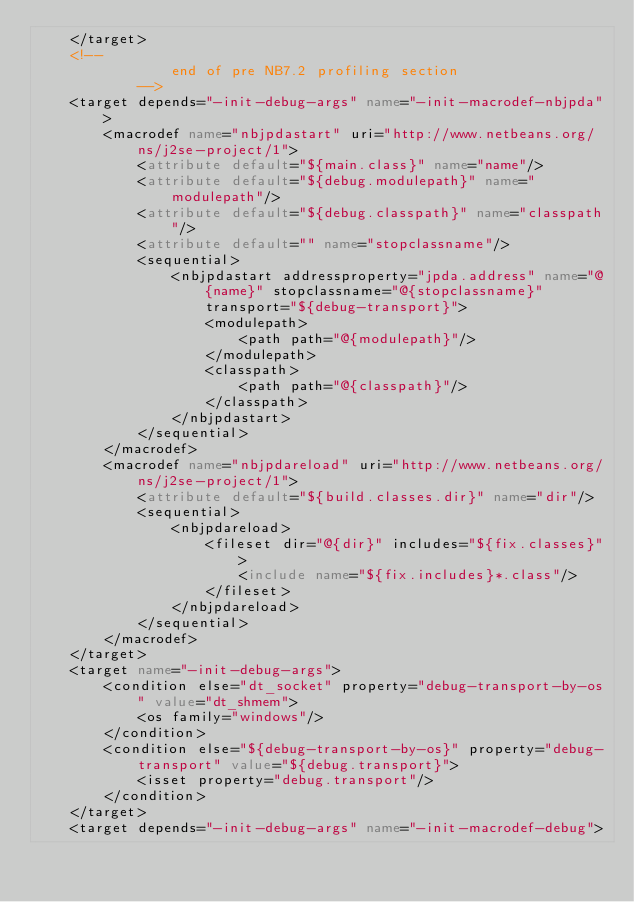<code> <loc_0><loc_0><loc_500><loc_500><_XML_>    </target>
    <!--
                end of pre NB7.2 profiling section
            -->
    <target depends="-init-debug-args" name="-init-macrodef-nbjpda">
        <macrodef name="nbjpdastart" uri="http://www.netbeans.org/ns/j2se-project/1">
            <attribute default="${main.class}" name="name"/>
            <attribute default="${debug.modulepath}" name="modulepath"/>
            <attribute default="${debug.classpath}" name="classpath"/>
            <attribute default="" name="stopclassname"/>
            <sequential>
                <nbjpdastart addressproperty="jpda.address" name="@{name}" stopclassname="@{stopclassname}" transport="${debug-transport}">
                    <modulepath>
                        <path path="@{modulepath}"/>
                    </modulepath>
                    <classpath>
                        <path path="@{classpath}"/>
                    </classpath>
                </nbjpdastart>
            </sequential>
        </macrodef>
        <macrodef name="nbjpdareload" uri="http://www.netbeans.org/ns/j2se-project/1">
            <attribute default="${build.classes.dir}" name="dir"/>
            <sequential>
                <nbjpdareload>
                    <fileset dir="@{dir}" includes="${fix.classes}">
                        <include name="${fix.includes}*.class"/>
                    </fileset>
                </nbjpdareload>
            </sequential>
        </macrodef>
    </target>
    <target name="-init-debug-args">
        <condition else="dt_socket" property="debug-transport-by-os" value="dt_shmem">
            <os family="windows"/>
        </condition>
        <condition else="${debug-transport-by-os}" property="debug-transport" value="${debug.transport}">
            <isset property="debug.transport"/>
        </condition>
    </target>
    <target depends="-init-debug-args" name="-init-macrodef-debug"></code> 